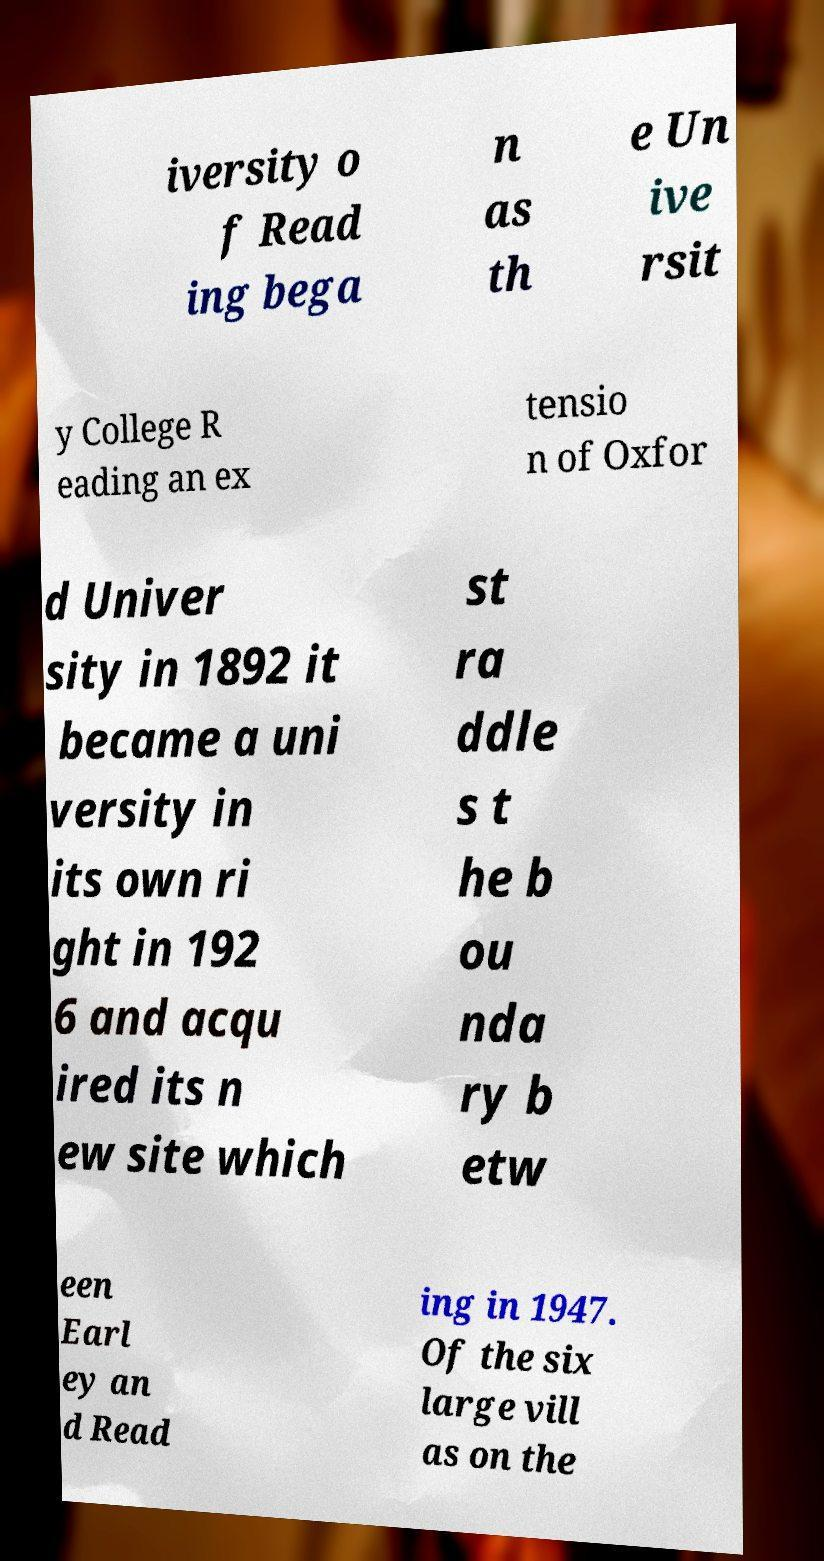Please read and relay the text visible in this image. What does it say? iversity o f Read ing bega n as th e Un ive rsit y College R eading an ex tensio n of Oxfor d Univer sity in 1892 it became a uni versity in its own ri ght in 192 6 and acqu ired its n ew site which st ra ddle s t he b ou nda ry b etw een Earl ey an d Read ing in 1947. Of the six large vill as on the 